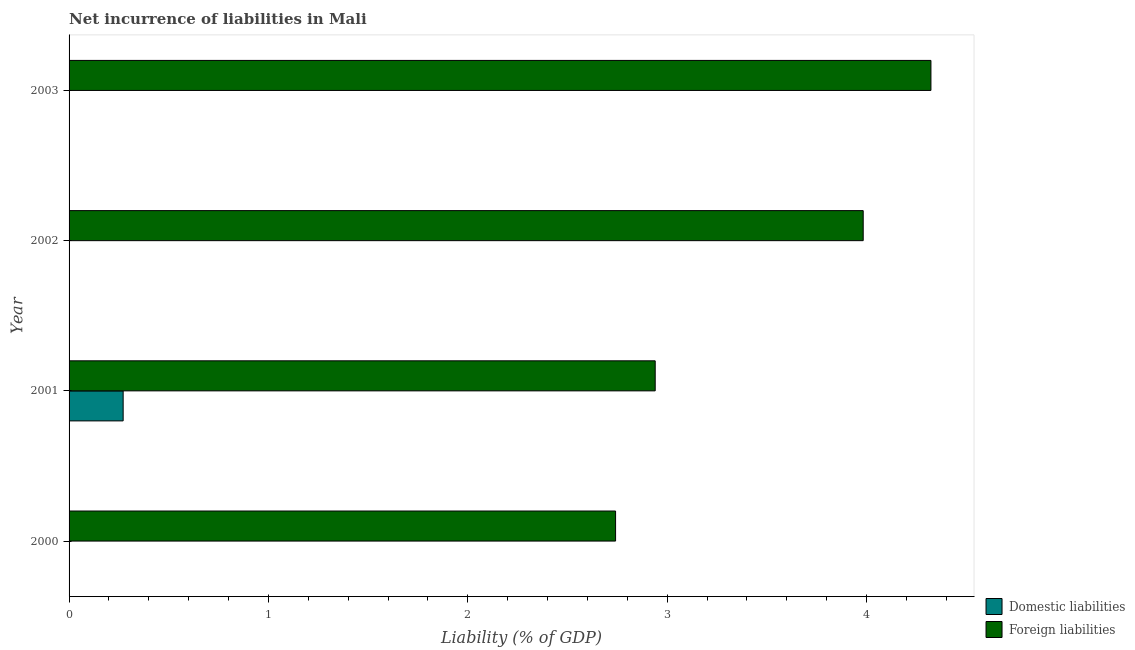Are the number of bars on each tick of the Y-axis equal?
Provide a succinct answer. No. How many bars are there on the 4th tick from the top?
Make the answer very short. 1. In how many cases, is the number of bars for a given year not equal to the number of legend labels?
Provide a succinct answer. 3. What is the incurrence of domestic liabilities in 2003?
Your response must be concise. 0. Across all years, what is the maximum incurrence of domestic liabilities?
Provide a short and direct response. 0.27. Across all years, what is the minimum incurrence of foreign liabilities?
Provide a succinct answer. 2.74. In which year was the incurrence of foreign liabilities maximum?
Your response must be concise. 2003. What is the total incurrence of foreign liabilities in the graph?
Provide a short and direct response. 13.99. What is the difference between the incurrence of foreign liabilities in 2000 and that in 2002?
Your answer should be very brief. -1.24. What is the difference between the incurrence of domestic liabilities in 2000 and the incurrence of foreign liabilities in 2002?
Your answer should be compact. -3.98. What is the average incurrence of foreign liabilities per year?
Provide a succinct answer. 3.5. In the year 2001, what is the difference between the incurrence of foreign liabilities and incurrence of domestic liabilities?
Give a very brief answer. 2.67. What is the ratio of the incurrence of foreign liabilities in 2002 to that in 2003?
Ensure brevity in your answer.  0.92. Is the incurrence of foreign liabilities in 2002 less than that in 2003?
Your answer should be very brief. Yes. What is the difference between the highest and the second highest incurrence of foreign liabilities?
Provide a short and direct response. 0.34. What is the difference between the highest and the lowest incurrence of foreign liabilities?
Your answer should be very brief. 1.58. In how many years, is the incurrence of foreign liabilities greater than the average incurrence of foreign liabilities taken over all years?
Make the answer very short. 2. Is the sum of the incurrence of foreign liabilities in 2001 and 2002 greater than the maximum incurrence of domestic liabilities across all years?
Give a very brief answer. Yes. What is the difference between two consecutive major ticks on the X-axis?
Make the answer very short. 1. Does the graph contain any zero values?
Make the answer very short. Yes. How many legend labels are there?
Offer a terse response. 2. How are the legend labels stacked?
Give a very brief answer. Vertical. What is the title of the graph?
Your answer should be compact. Net incurrence of liabilities in Mali. What is the label or title of the X-axis?
Provide a short and direct response. Liability (% of GDP). What is the label or title of the Y-axis?
Provide a short and direct response. Year. What is the Liability (% of GDP) in Domestic liabilities in 2000?
Make the answer very short. 0. What is the Liability (% of GDP) in Foreign liabilities in 2000?
Your response must be concise. 2.74. What is the Liability (% of GDP) of Domestic liabilities in 2001?
Provide a short and direct response. 0.27. What is the Liability (% of GDP) of Foreign liabilities in 2001?
Give a very brief answer. 2.94. What is the Liability (% of GDP) of Domestic liabilities in 2002?
Keep it short and to the point. 0. What is the Liability (% of GDP) in Foreign liabilities in 2002?
Keep it short and to the point. 3.98. What is the Liability (% of GDP) of Domestic liabilities in 2003?
Your answer should be very brief. 0. What is the Liability (% of GDP) of Foreign liabilities in 2003?
Your response must be concise. 4.32. Across all years, what is the maximum Liability (% of GDP) in Domestic liabilities?
Your answer should be compact. 0.27. Across all years, what is the maximum Liability (% of GDP) in Foreign liabilities?
Make the answer very short. 4.32. Across all years, what is the minimum Liability (% of GDP) in Foreign liabilities?
Ensure brevity in your answer.  2.74. What is the total Liability (% of GDP) in Domestic liabilities in the graph?
Keep it short and to the point. 0.27. What is the total Liability (% of GDP) in Foreign liabilities in the graph?
Offer a terse response. 13.99. What is the difference between the Liability (% of GDP) in Foreign liabilities in 2000 and that in 2001?
Make the answer very short. -0.2. What is the difference between the Liability (% of GDP) in Foreign liabilities in 2000 and that in 2002?
Offer a terse response. -1.24. What is the difference between the Liability (% of GDP) of Foreign liabilities in 2000 and that in 2003?
Offer a very short reply. -1.58. What is the difference between the Liability (% of GDP) of Foreign liabilities in 2001 and that in 2002?
Your answer should be compact. -1.04. What is the difference between the Liability (% of GDP) in Foreign liabilities in 2001 and that in 2003?
Your answer should be very brief. -1.38. What is the difference between the Liability (% of GDP) in Foreign liabilities in 2002 and that in 2003?
Offer a terse response. -0.34. What is the difference between the Liability (% of GDP) in Domestic liabilities in 2001 and the Liability (% of GDP) in Foreign liabilities in 2002?
Your response must be concise. -3.71. What is the difference between the Liability (% of GDP) in Domestic liabilities in 2001 and the Liability (% of GDP) in Foreign liabilities in 2003?
Provide a short and direct response. -4.05. What is the average Liability (% of GDP) of Domestic liabilities per year?
Provide a succinct answer. 0.07. What is the average Liability (% of GDP) in Foreign liabilities per year?
Keep it short and to the point. 3.5. In the year 2001, what is the difference between the Liability (% of GDP) of Domestic liabilities and Liability (% of GDP) of Foreign liabilities?
Your answer should be compact. -2.67. What is the ratio of the Liability (% of GDP) in Foreign liabilities in 2000 to that in 2001?
Ensure brevity in your answer.  0.93. What is the ratio of the Liability (% of GDP) in Foreign liabilities in 2000 to that in 2002?
Provide a short and direct response. 0.69. What is the ratio of the Liability (% of GDP) of Foreign liabilities in 2000 to that in 2003?
Make the answer very short. 0.63. What is the ratio of the Liability (% of GDP) in Foreign liabilities in 2001 to that in 2002?
Make the answer very short. 0.74. What is the ratio of the Liability (% of GDP) of Foreign liabilities in 2001 to that in 2003?
Provide a succinct answer. 0.68. What is the ratio of the Liability (% of GDP) in Foreign liabilities in 2002 to that in 2003?
Offer a very short reply. 0.92. What is the difference between the highest and the second highest Liability (% of GDP) of Foreign liabilities?
Your response must be concise. 0.34. What is the difference between the highest and the lowest Liability (% of GDP) of Domestic liabilities?
Offer a very short reply. 0.27. What is the difference between the highest and the lowest Liability (% of GDP) in Foreign liabilities?
Your response must be concise. 1.58. 